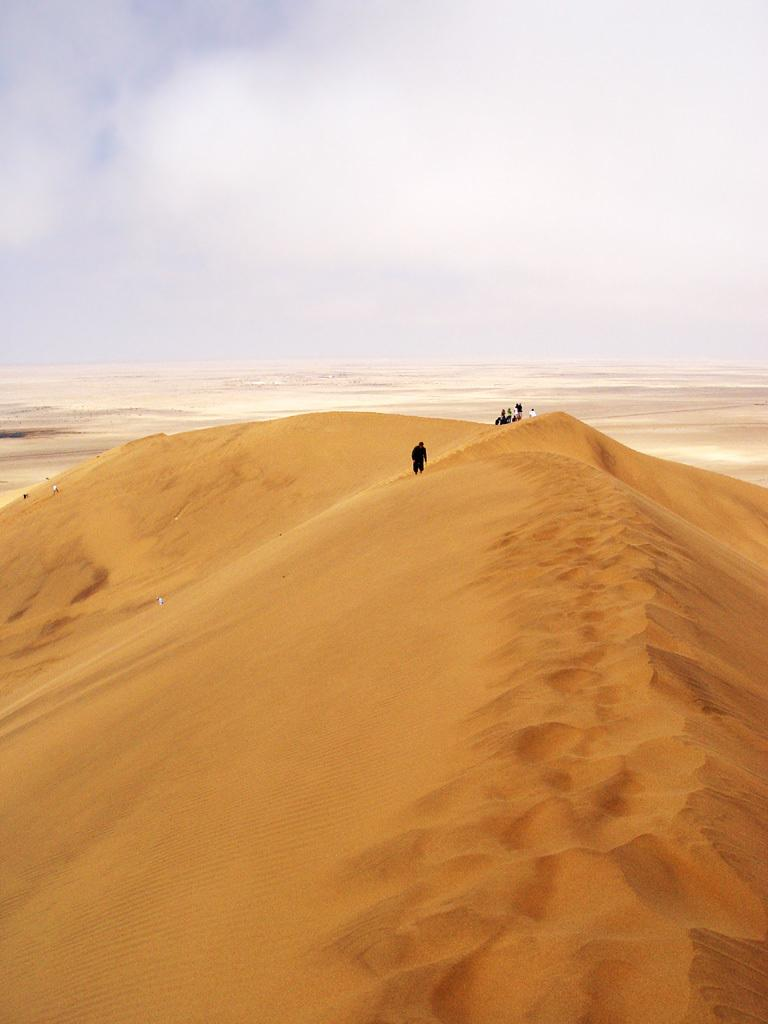What type of terrain is visible in the image? There is sand in the image. Who or what is present in the image? There are people in the image. What can be seen in the distance in the image? The sky is visible in the background of the image. How many dogs are learning to build a nest in the image? There are no dogs or nests present in the image. 